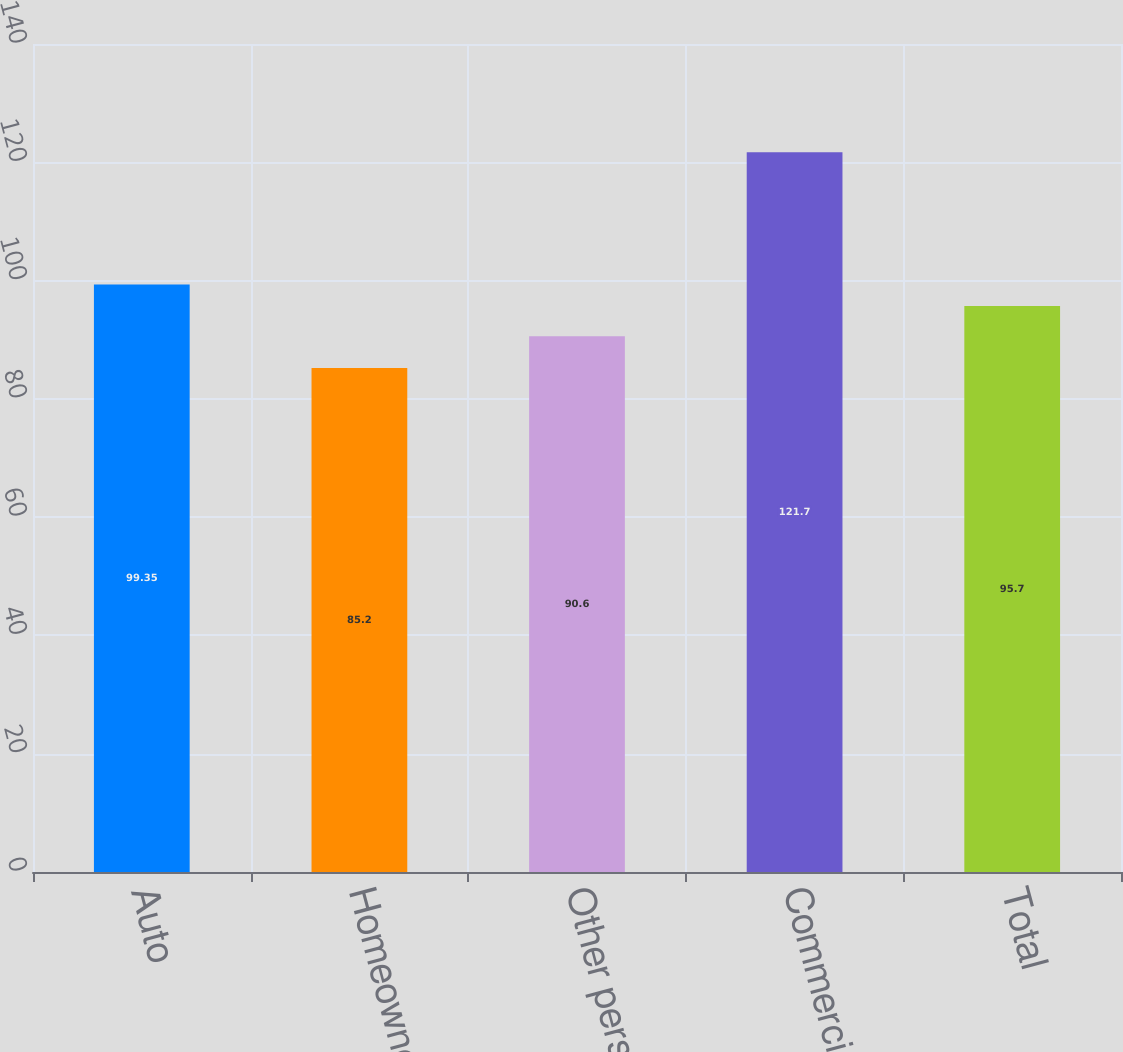Convert chart to OTSL. <chart><loc_0><loc_0><loc_500><loc_500><bar_chart><fcel>Auto<fcel>Homeowners<fcel>Other personal lines<fcel>Commercial lines<fcel>Total<nl><fcel>99.35<fcel>85.2<fcel>90.6<fcel>121.7<fcel>95.7<nl></chart> 